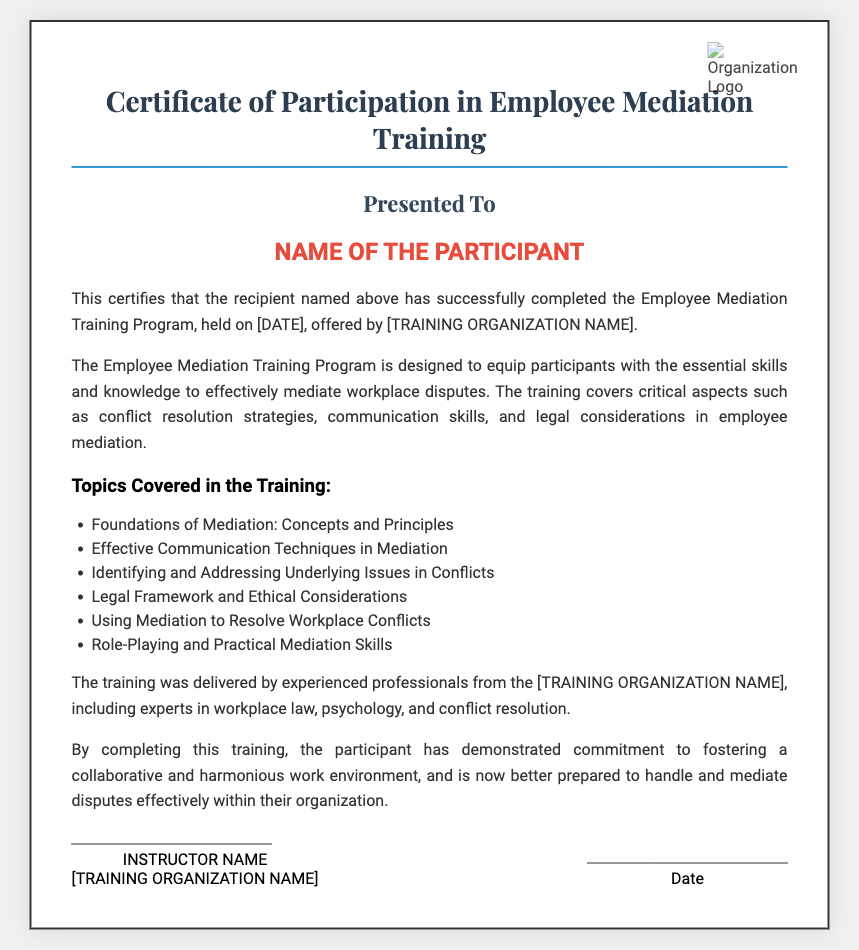What is the title of the document? The title is clearly stated at the top of the certificate.
Answer: Certificate of Participation in Employee Mediation Training Who is the recipient of the certificate? The recipient's name will be mentioned in the specified section of the document.
Answer: NAME OF THE PARTICIPANT What organization offered the training? The name of the training organization is mentioned in the certificate.
Answer: [TRAINING ORGANIZATION NAME] What is the date of the training program? The specific date of the training program is noted in the document.
Answer: [DATE] What is one topic covered in the training? The document lists several topics in a bulleted format.
Answer: Foundations of Mediation: Concepts and Principles What skill is emphasized in the Employee Mediation Training Program? The document states the goal of the program regarding workplace disputes.
Answer: Conflict resolution strategies What evidence of completion is given for the participant? The participant's successful completion is confirmed in the text of the document.
Answer: Successfully completed the Employee Mediation Training Program Who delivered the training? The document mentions the professionals involved in the training.
Answer: Experienced professionals from the [TRAINING ORGANIZATION NAME] What does the participant demonstrate by completing the training? The document emphasizes the commitment inferred from training completion.
Answer: Commitment to fostering a collaborative and harmonious work environment 